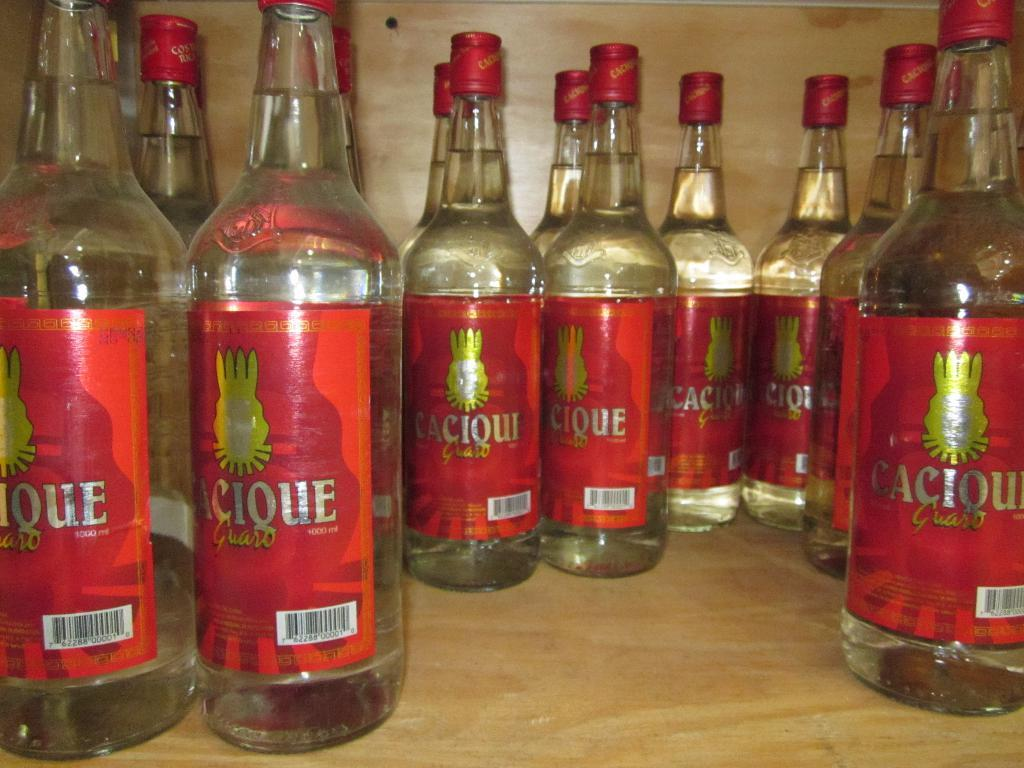<image>
Describe the image concisely. Several 1000 ml bottles of Cique are stored in a cabinet. 